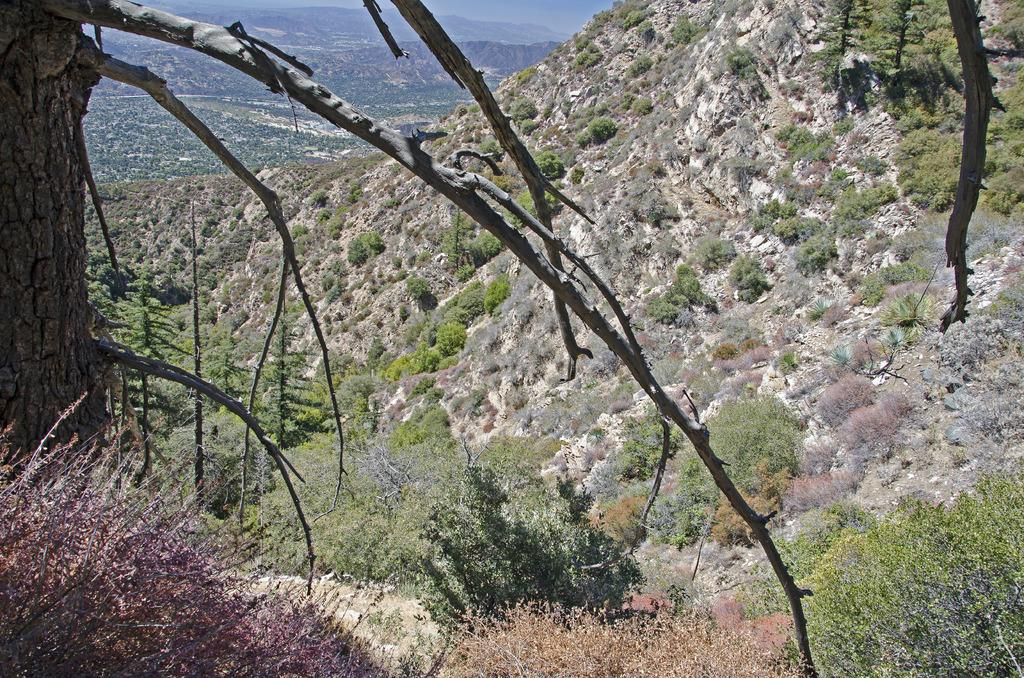What is the main subject of the image? The main subject of the image is a tree trunk. What else can be seen in the image besides the tree trunk? There are branches, plants, and mountains in the image. What type of payment is being made in the image? There is no payment being made in the image; it features a tree trunk, branches, plants, and mountains. 